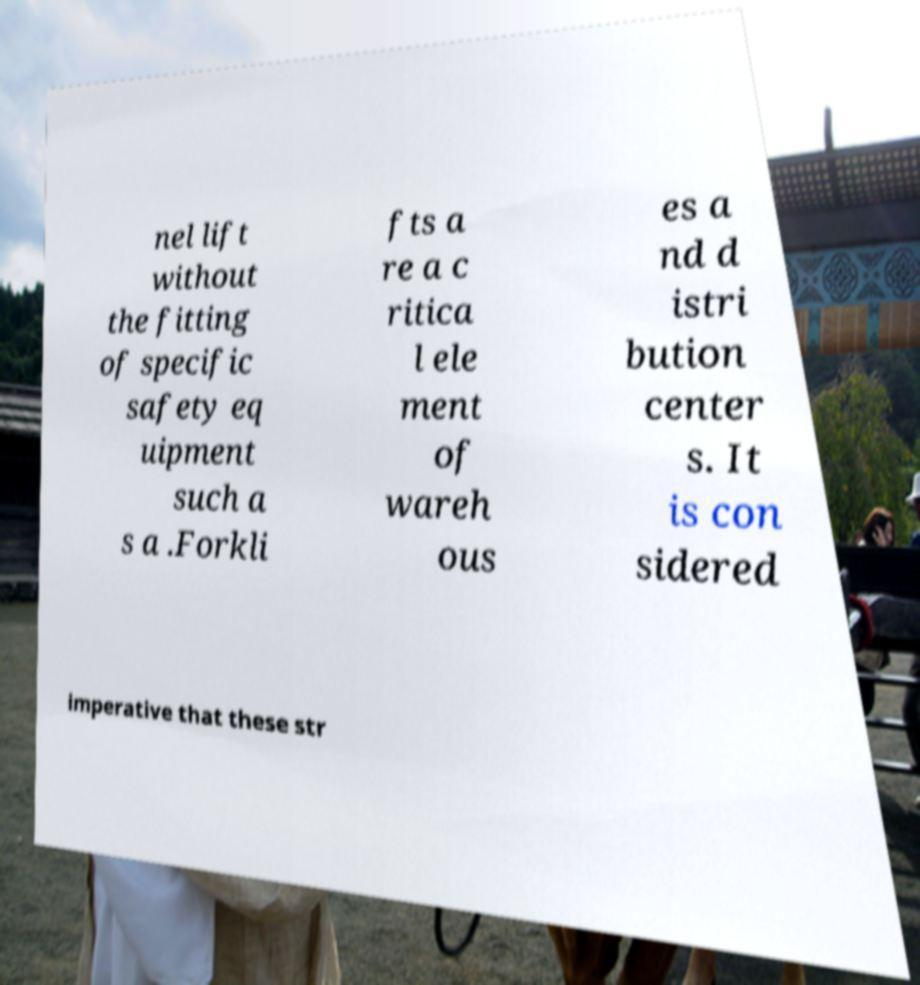I need the written content from this picture converted into text. Can you do that? nel lift without the fitting of specific safety eq uipment such a s a .Forkli fts a re a c ritica l ele ment of wareh ous es a nd d istri bution center s. It is con sidered imperative that these str 